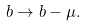Convert formula to latex. <formula><loc_0><loc_0><loc_500><loc_500>b \rightarrow b - \mu .</formula> 